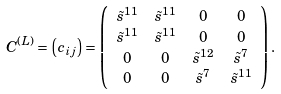<formula> <loc_0><loc_0><loc_500><loc_500>C ^ { ( L ) } & = \left ( c _ { i j } \right ) = \left ( \begin{array} { c c c c } \tilde { s } ^ { 1 1 } & \tilde { s } ^ { 1 1 } & 0 & 0 \\ \tilde { s } ^ { 1 1 } & \tilde { s } ^ { 1 1 } & 0 & 0 \\ 0 & 0 & \tilde { s } ^ { 1 2 } & \tilde { s } ^ { 7 } \\ 0 & 0 & \tilde { s } ^ { 7 } & \tilde { s } ^ { 1 1 } \\ \end{array} \right ) .</formula> 